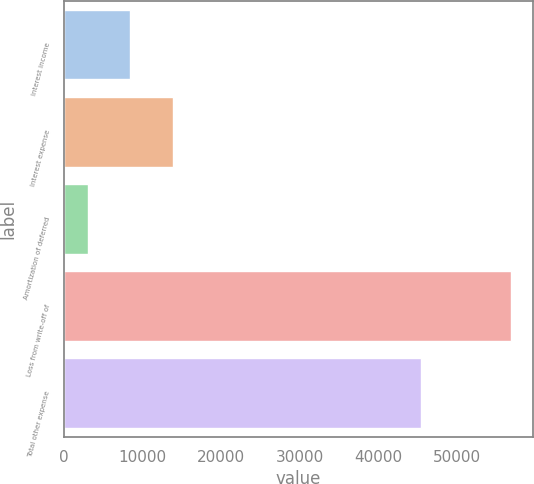<chart> <loc_0><loc_0><loc_500><loc_500><bar_chart><fcel>Interest income<fcel>Interest expense<fcel>Amortization of deferred<fcel>Loss from write-off of<fcel>Total other expense<nl><fcel>8425.2<fcel>13800.4<fcel>3050<fcel>56802<fcel>45381<nl></chart> 